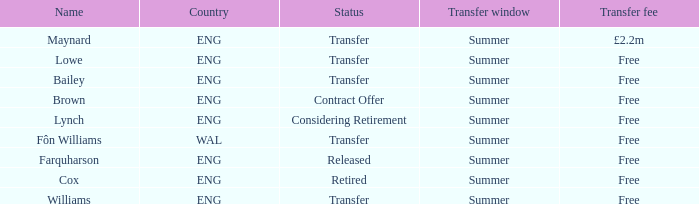What is Brown's transfer window? Summer. 